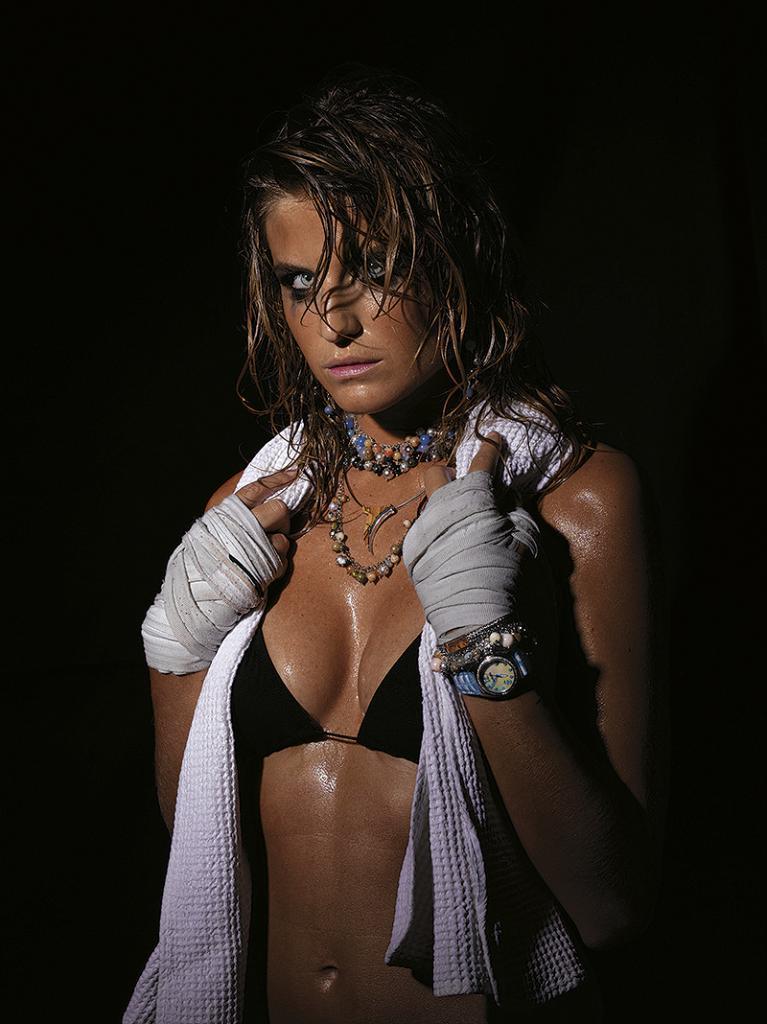Can you describe this image briefly? In this image we can see a woman. The background is dark. 